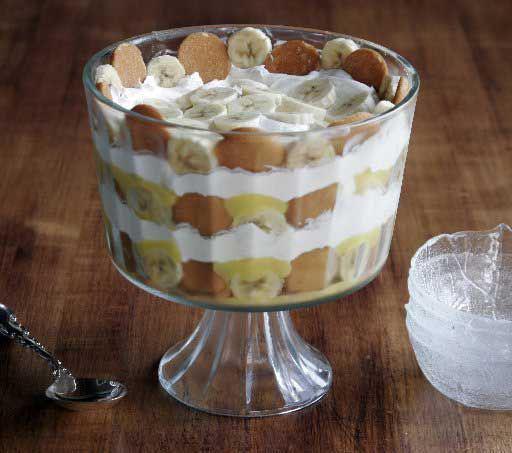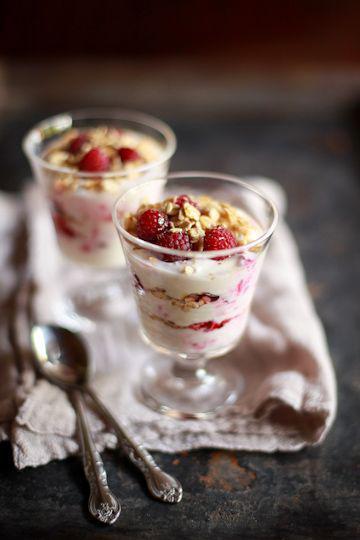The first image is the image on the left, the second image is the image on the right. For the images shown, is this caption "There are two servings of desserts in the image on the right." true? Answer yes or no. Yes. 